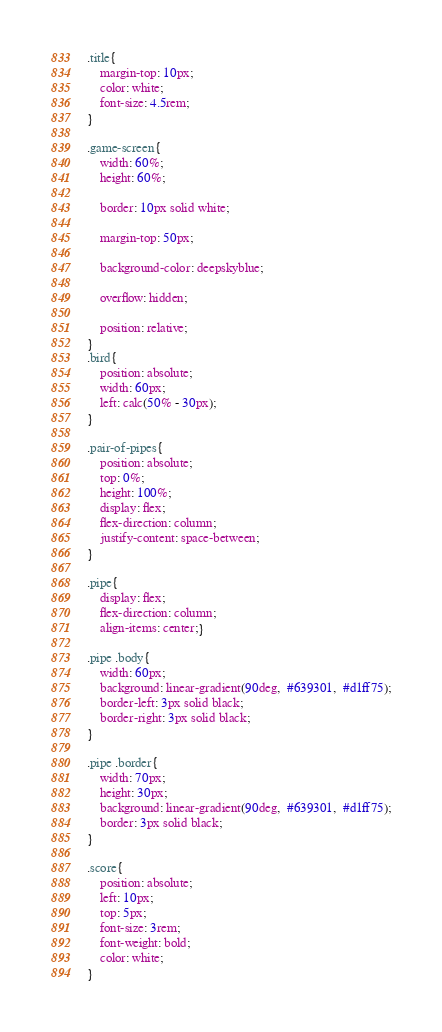Convert code to text. <code><loc_0><loc_0><loc_500><loc_500><_CSS_>.title{
    margin-top: 10px;
    color: white;
    font-size: 4.5rem;
}

.game-screen{
    width: 60%;
    height: 60%;

    border: 10px solid white;

    margin-top: 50px;

    background-color: deepskyblue;

    overflow: hidden;

    position: relative;
}
.bird{
    position: absolute;
    width: 60px;
    left: calc(50% - 30px);
}

.pair-of-pipes{
    position: absolute;
    top: 0%;
    height: 100%;
    display: flex;
    flex-direction: column;
    justify-content: space-between;
}

.pipe{
    display: flex;
    flex-direction: column;
    align-items: center;}

.pipe .body{
    width: 60px;
    background: linear-gradient(90deg,  #639301,  #d1ff75);
    border-left: 3px solid black;
    border-right: 3px solid black;
}

.pipe .border{
    width: 70px;
    height: 30px;
    background: linear-gradient(90deg,  #639301,  #d1ff75);
    border: 3px solid black;
}

.score{
    position: absolute;
    left: 10px;
    top: 5px;
    font-size: 3rem;
    font-weight: bold;
    color: white;
}</code> 